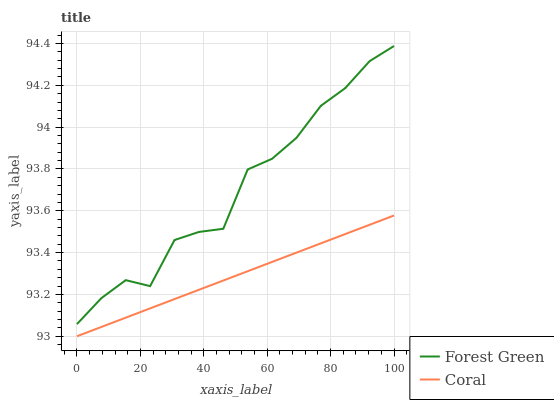Does Coral have the minimum area under the curve?
Answer yes or no. Yes. Does Forest Green have the maximum area under the curve?
Answer yes or no. Yes. Does Coral have the maximum area under the curve?
Answer yes or no. No. Is Coral the smoothest?
Answer yes or no. Yes. Is Forest Green the roughest?
Answer yes or no. Yes. Is Coral the roughest?
Answer yes or no. No. Does Coral have the lowest value?
Answer yes or no. Yes. Does Forest Green have the highest value?
Answer yes or no. Yes. Does Coral have the highest value?
Answer yes or no. No. Is Coral less than Forest Green?
Answer yes or no. Yes. Is Forest Green greater than Coral?
Answer yes or no. Yes. Does Coral intersect Forest Green?
Answer yes or no. No. 